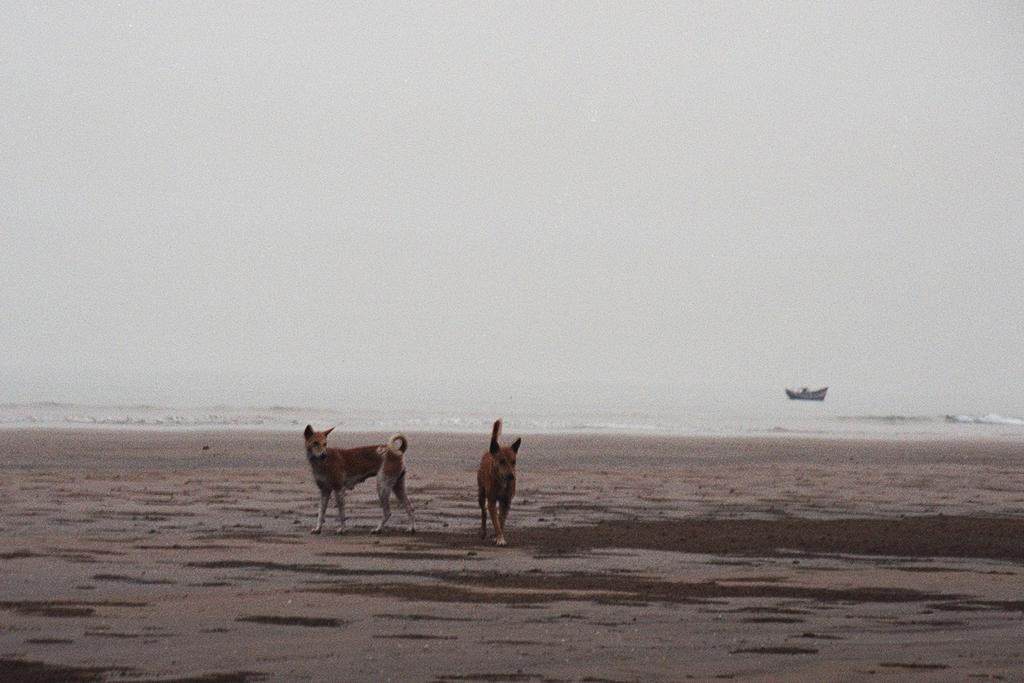How many dogs are present in the image? There are two dogs in the image. Where are the dogs located? The dogs are on a path in the image. What else can be seen in the image besides the dogs? There is a boat visible in the image. Can you describe the location of the boat? The boat is on the water in the image. What type of flowers can be seen growing near the dogs in the image? There are no flowers present in the image; it only features two dogs on a path and a boat on the water. 